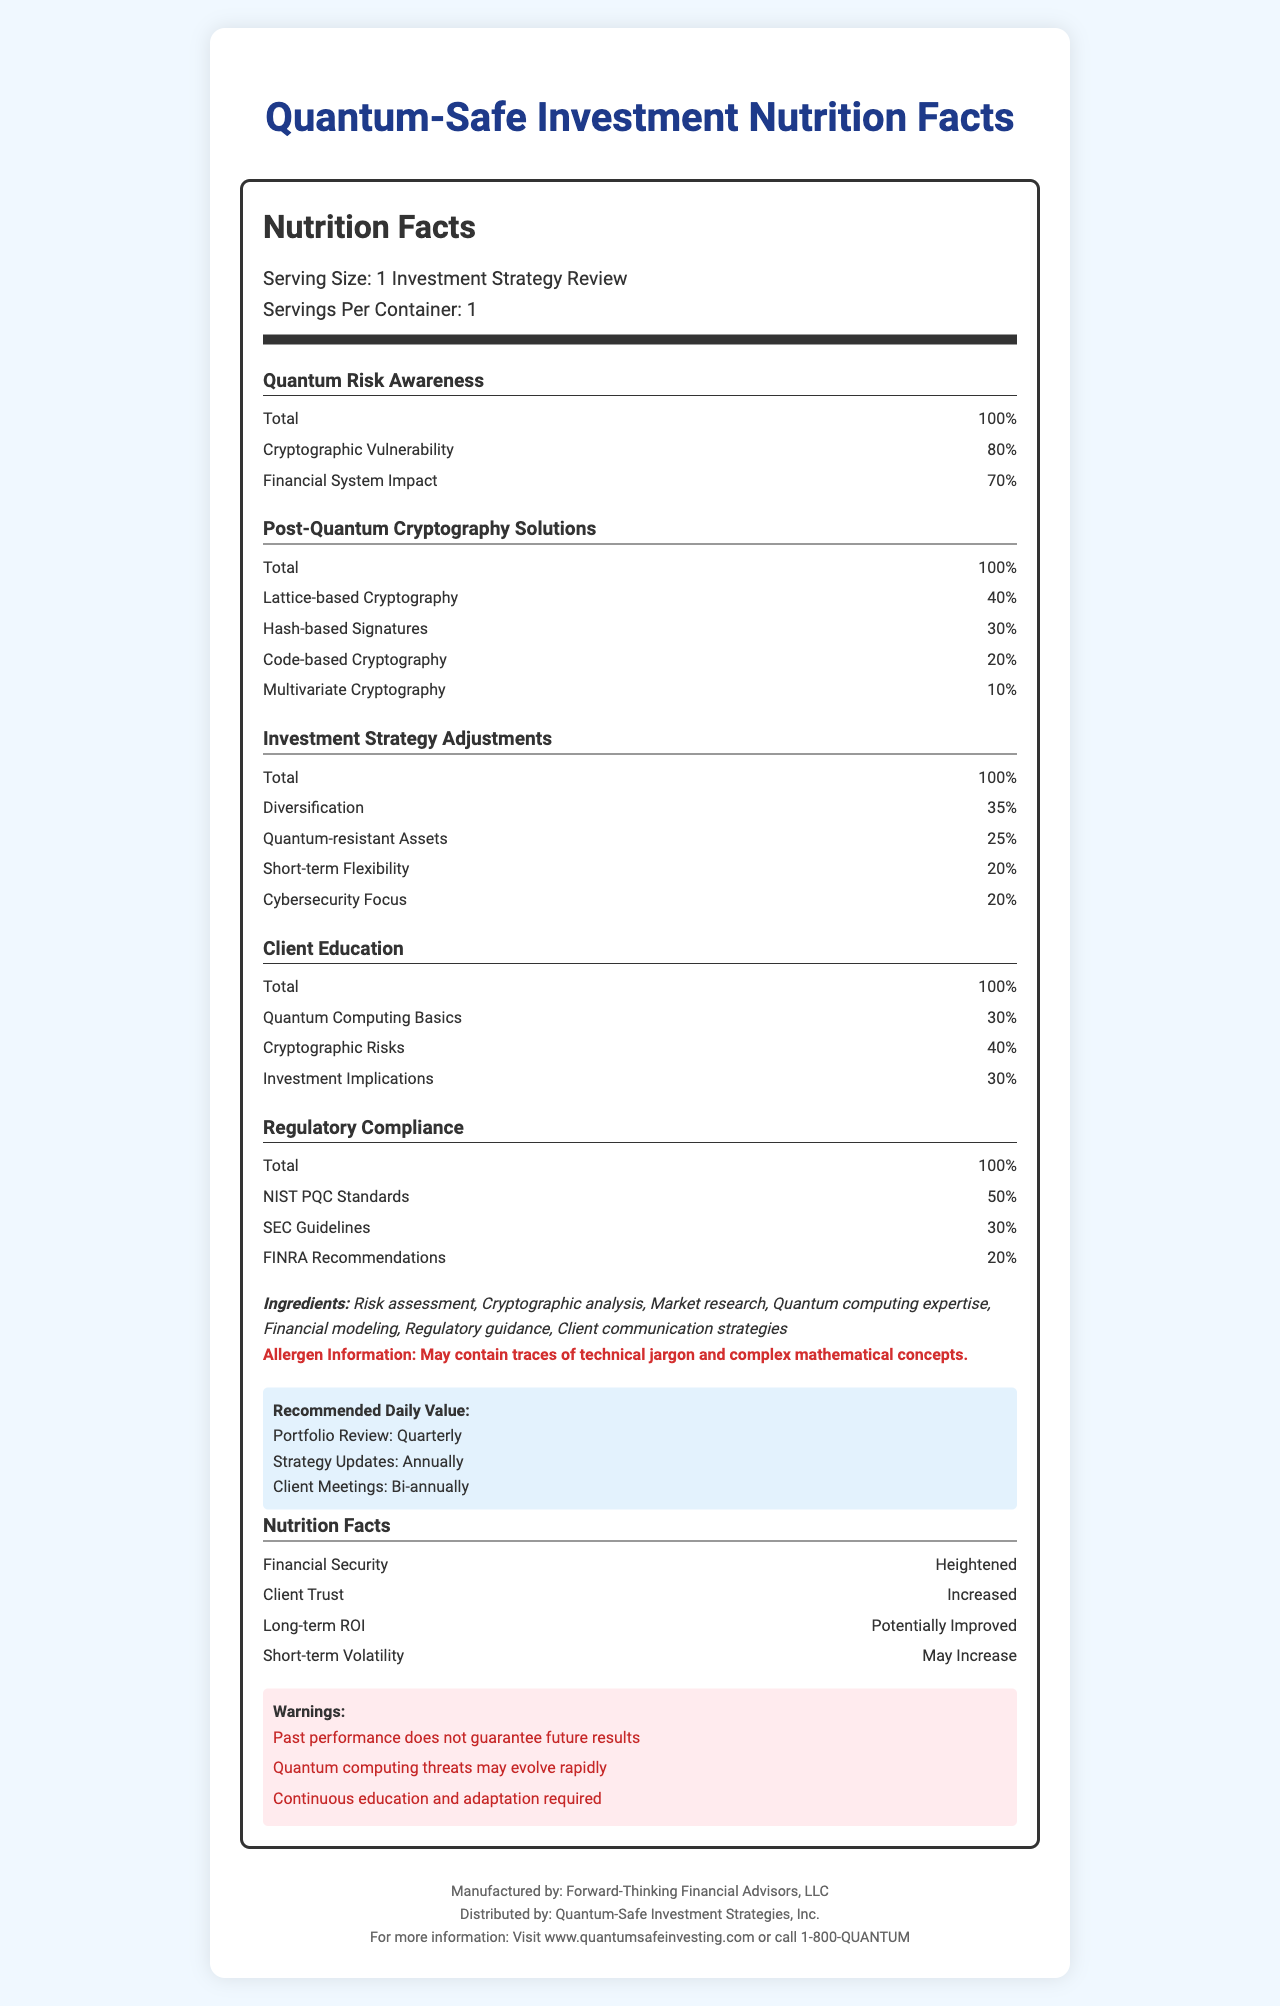what is the serving size mentioned in the document? The Serving Size is explicitly mentioned as "1 Investment Strategy Review" under the Nutrition Facts header.
Answer: 1 Investment Strategy Review how much is the Cryptographic Vulnerability percentage? Under the "Quantum Risk Awareness" section, it lists Cryptographic Vulnerability as 80%.
Answer: 80% which cryptographic solution has the highest percentage? Under the "Post-Quantum Cryptography Solutions" section, Lattice-based Cryptography has the highest percentage at 40%.
Answer: Lattice-based Cryptography how often should the Portfolio Review be conducted? In the "Recommended Daily Value" section, it states Portfolio Review: Quarterly.
Answer: Quarterly what is the Total percentage for Investment Strategy Adjustments? The Total percentage for Investment Strategy Adjustments is clearly indicated as 100%.
Answer: 100% how much focus is given to Cybersecurity in investment strategy adjustments? Under the "Investment Strategy Adjustments" section, Cybersecurity Focus is listed as 20%.
Answer: 20% what are some ingredients listed in the document? The document lists these ingredients under the "Ingredients" section.
Answer: Risk assessment, Cryptographic analysis, Market research, Quantum computing expertise, Financial modeling, Regulatory guidance, Client communication strategies which regulatory compliance standard has the highest percentage? A. SEC Guidelines B. FINRA Recommendations C. NIST PQC Standards Under the "Regulatory Compliance" section, NIST PQC Standards have the highest percentage at 50%.
Answer: C what is the main objective of the document? The document details various aspects such as risk awareness, cryptographic solutions, strategy adjustments, client education, and regulatory compliance to secure investment strategies against quantum computing threats.
Answer: To provide a comprehensive overview of how to secure investment strategies considering quantum computing threats is client education focused more on Quantum Computing Basics or Cryptographic Risks? Under the "Client Education" section, Cryptographic Risks are given a higher percentage (40%) compared to Quantum Computing Basics (30%).
Answer: Cryptographic Risks does the document ensure a guarantee for future results? Under the "Warnings" section, it explicitly states "Past performance does not guarantee future results".
Answer: No what is the recommended frequency for Client Meetings? Under the "Recommended Daily Value" section, it states Client Meetings: Bi-annually.
Answer: Bi-annually what impacts might quantum computing threats have according to the warnings? A. Evolution of threats B. Stable investment results C. No need for continuous education The "Warnings" section mentions "Quantum computing threats may evolve rapidly."
Answer: A how does the document list the impact on Financial Security? Under the "Nutrition Facts" section, it lists Financial Security as "Heightened".
Answer: Heightened what does the allergen information indicate? The "Allergen Information" specifies that it may contain technical jargon and complex mathematical concepts.
Answer: May contain traces of technical jargon and complex mathematical concepts. are the percentages in the document realistic figures or hypothetical? The document provides percentages, but there is no additional context or source information to confirm their realism.
Answer: Cannot be determined describe the main idea of the document The main idea is to offer a comprehensive guide for financial advisors on securing investments against quantum computing threats, detailing various components and their importance in the strategy.
Answer: The document is designed like a Nutrition Facts Label to provide a detailed overview of how traditional investment strategies could be impacted by quantum computing. Key aspects include Quantum Risk Awareness, Post-Quantum Cryptography Solutions, Investment Strategy Adjustments, Client Education, Regulatory Compliance, and various considerations and warnings related to these areas. 